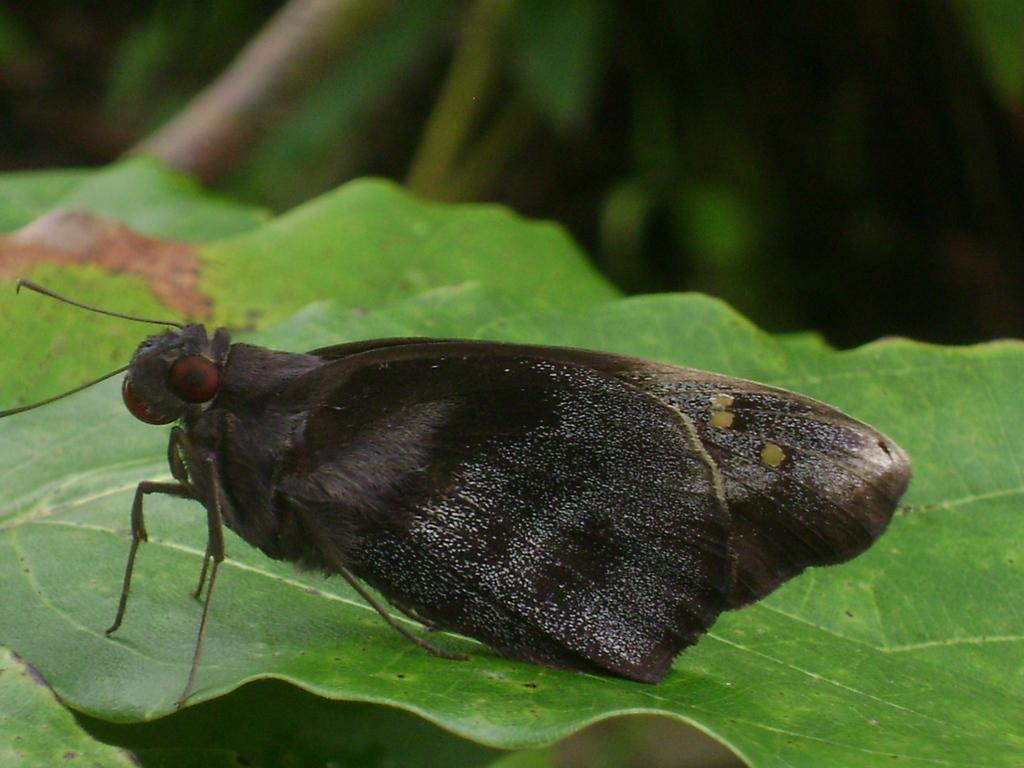Can you describe this image briefly? In the middle of the image we can see an insect on the leaf and we can see blurry background. 